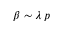<formula> <loc_0><loc_0><loc_500><loc_500>\beta \sim \lambda \, p</formula> 